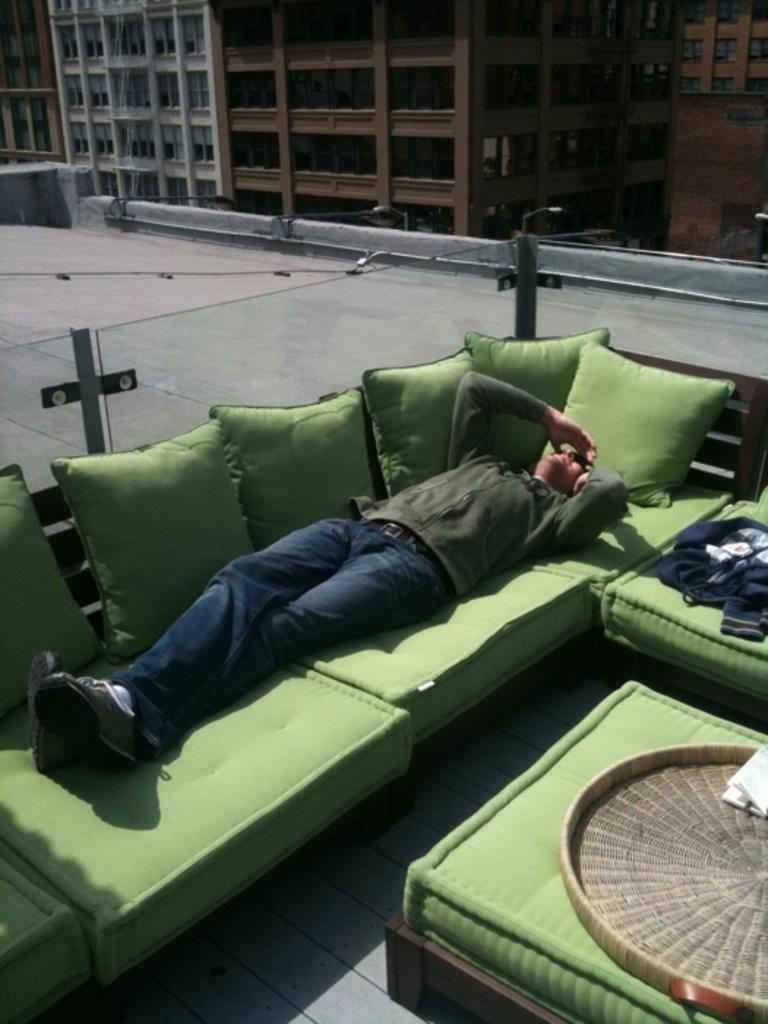In one or two sentences, can you explain what this image depicts? In this image, there is a person wearing clothes and footwear. This person is sleeping on the sofa. There is a building at the top of this image. 